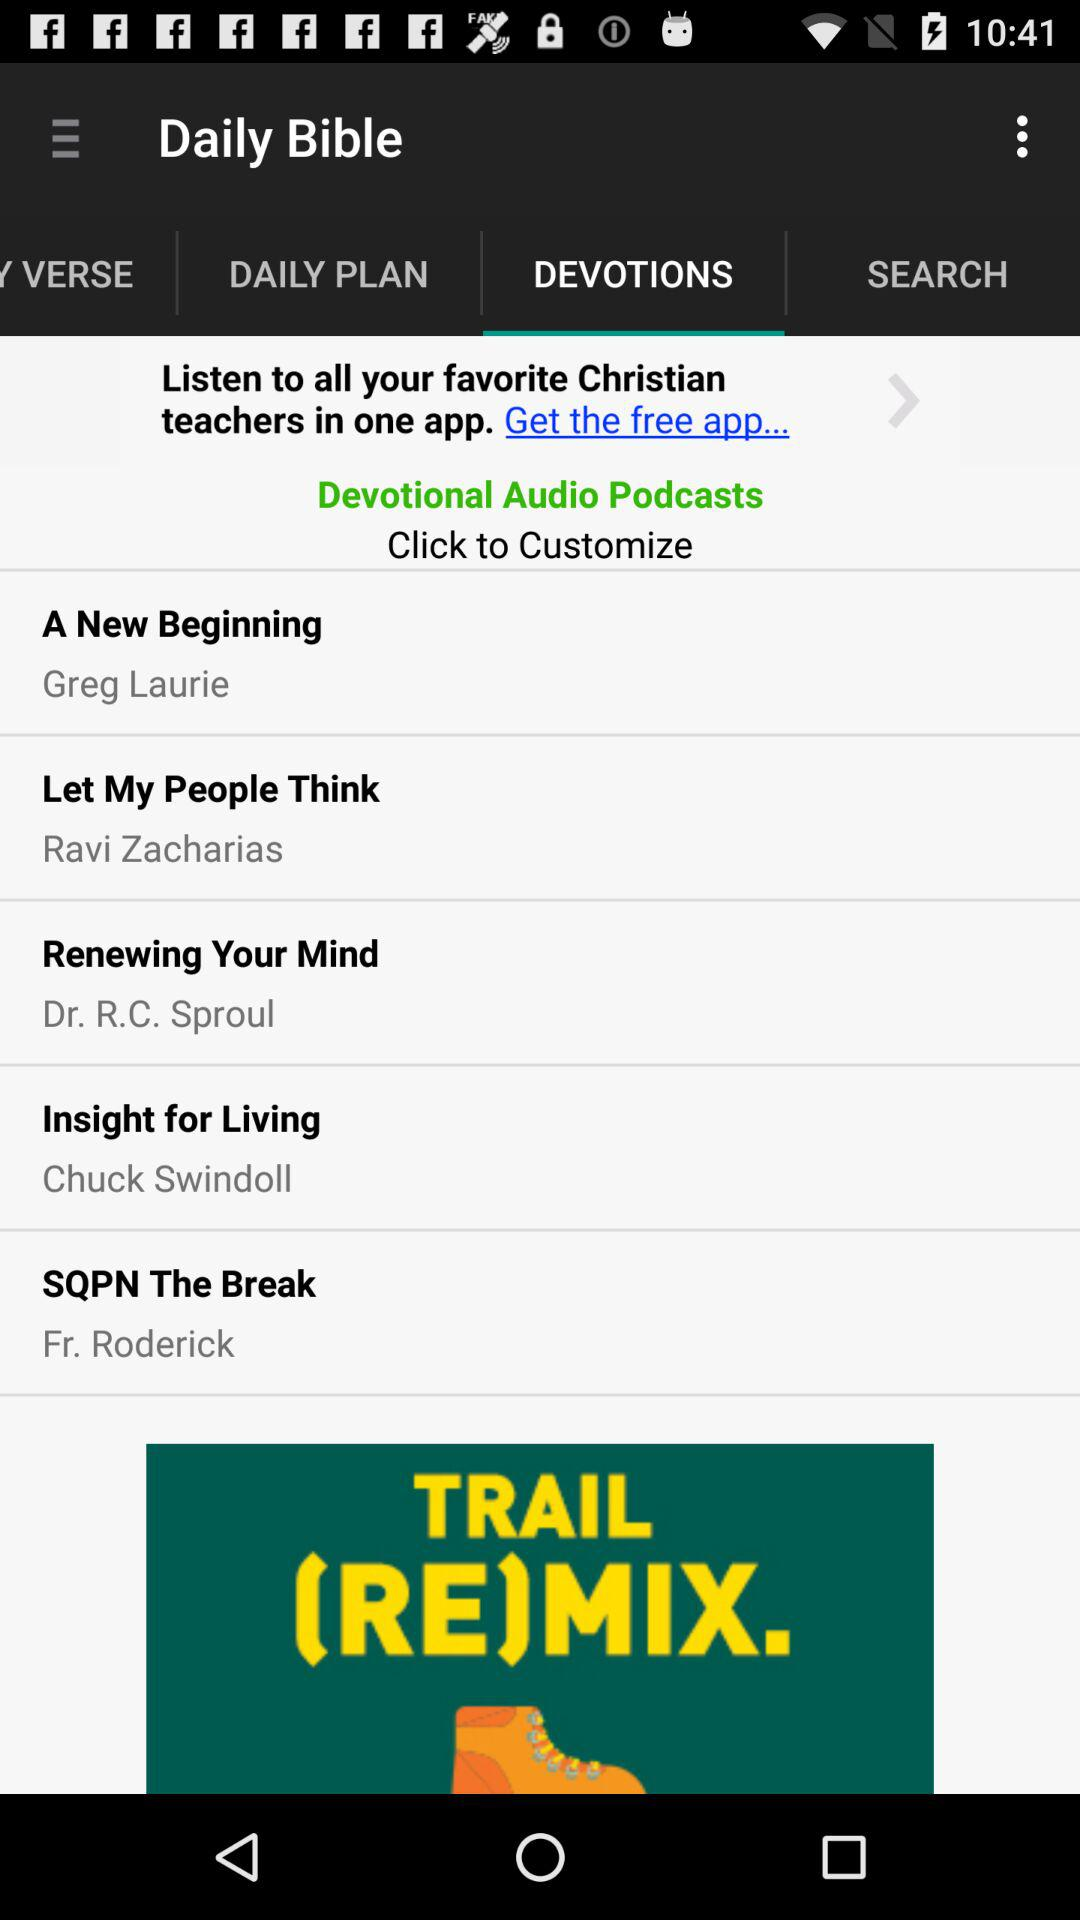What is the name of the application? The application name is "Daily Bible". 